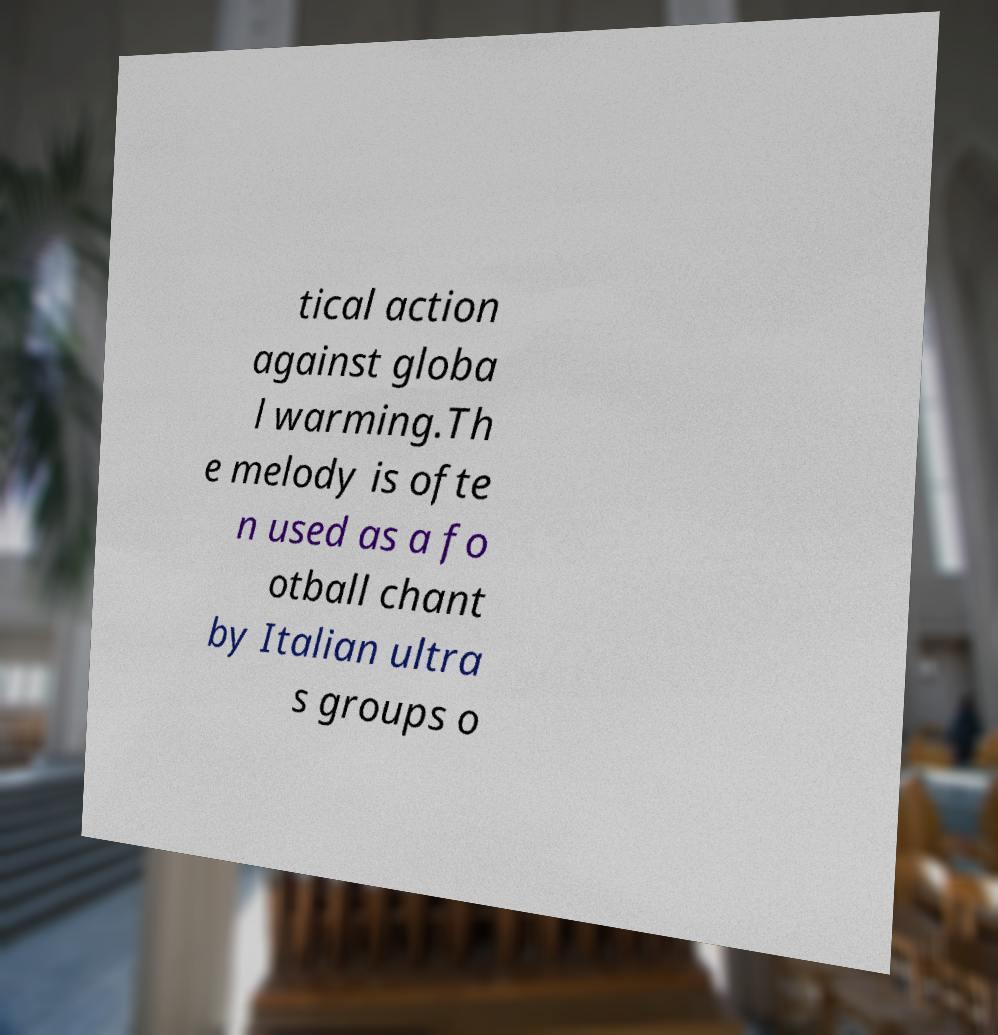There's text embedded in this image that I need extracted. Can you transcribe it verbatim? tical action against globa l warming.Th e melody is ofte n used as a fo otball chant by Italian ultra s groups o 